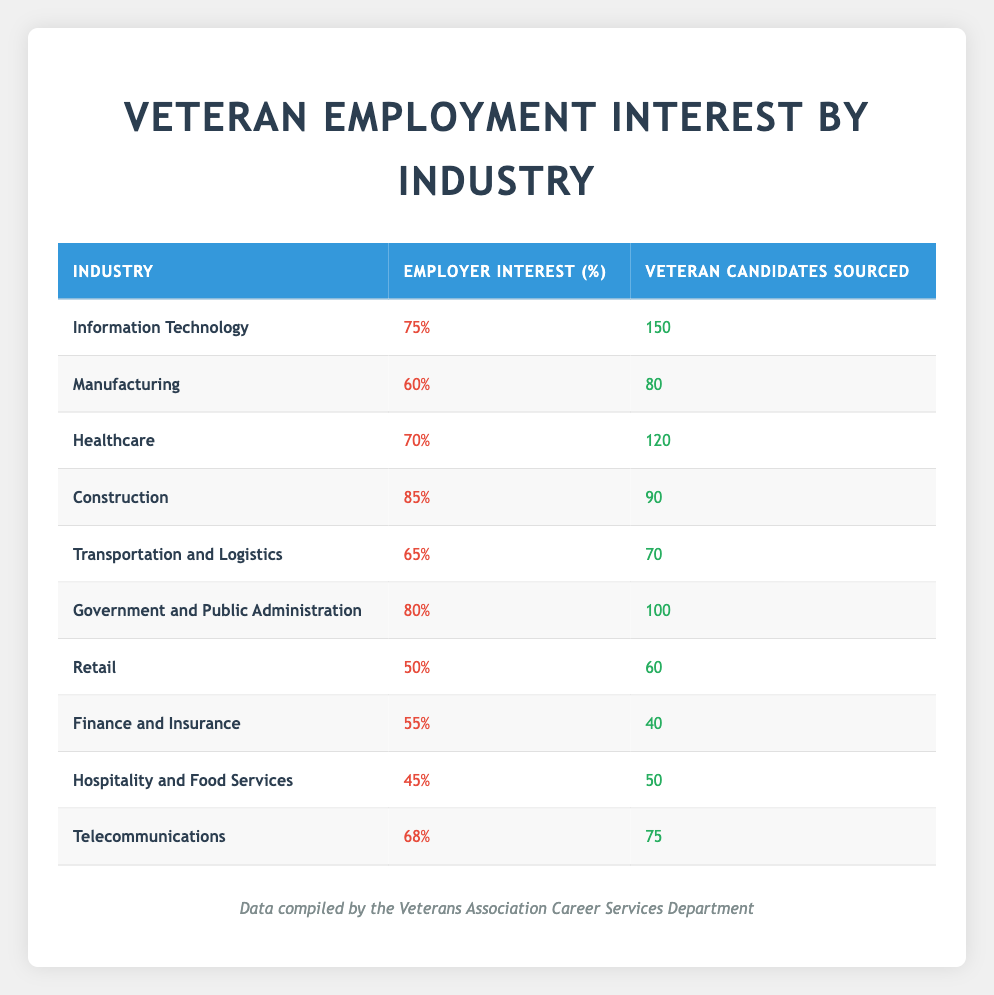What industry has the highest employer interest for veteran candidates? The table indicates that the Construction industry has the highest employer interest level at 85%.
Answer: Construction How many veteran candidates were sourced in the Healthcare industry? According to the table, the Healthcare industry sourced 120 veteran candidates.
Answer: 120 What is the total employer interest percentage for the top three industries with the highest interest? The top three industries with the highest employer interest are Construction (85%), Government and Public Administration (80%), and Information Technology (75%). The total interest is 85 + 80 + 75 = 240%.
Answer: 240% In which industry is the least percentage of employer interest shown? The Retail industry shows the least percentage of employer interest at 50%.
Answer: Retail Are there more veteran candidates sourced in Information Technology than in Finance and Insurance? Yes, Information Technology sourced 150 veteran candidates, while Finance and Insurance only sourced 40.
Answer: Yes What is the average employer interest percentage across all industries listed in the table? To find the average, sum up the employer interest percentages: 75 + 60 + 70 + 85 + 65 + 80 + 50 + 55 + 45 + 68 =  70.8 and divide by 10 (the number of industries), which gives an average of 70.8%.
Answer: 70.8% Which industry has a higher employer interest, Healthcare or Transportation and Logistics? Healthcare has an employer interest of 70%, whereas Transportation and Logistics has 65%. Therefore, Healthcare has a higher interest level.
Answer: Healthcare How many veteran candidates were sourced in the Telecommunications industry? The table shows that the Telecommunications industry sourced 75 veteran candidates.
Answer: 75 Is employer interest higher in Government and Public Administration than in Manufacturing? Yes, Government and Public Administration has an employer interest of 80%, which is higher than Manufacturing's 60%.
Answer: Yes 